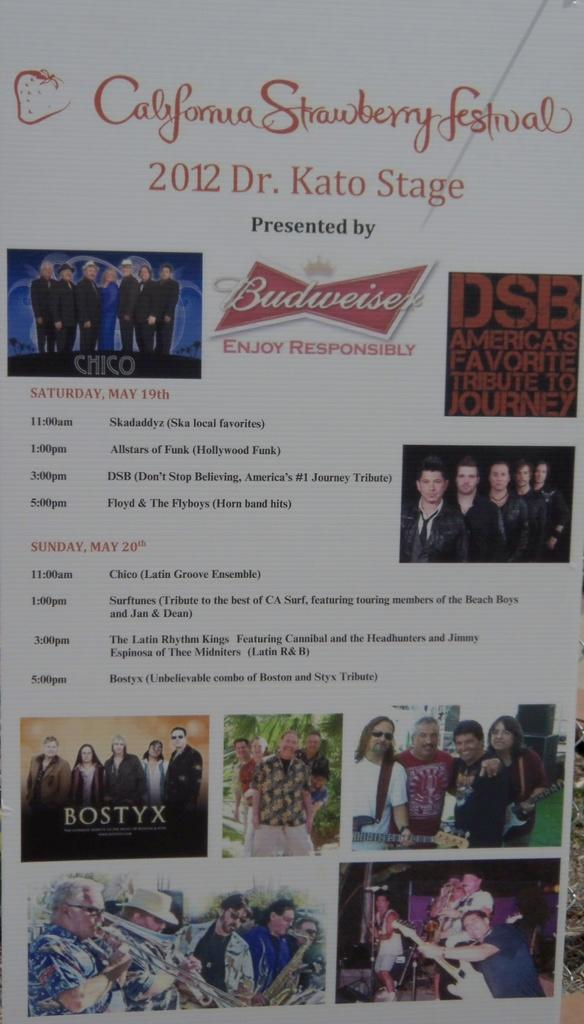<image>
Summarize the visual content of the image. A promotional sign giving the sponsors and activities at the California Strawberry Festival. 